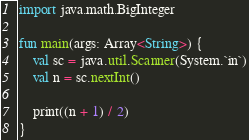<code> <loc_0><loc_0><loc_500><loc_500><_Kotlin_>import java.math.BigInteger

fun main(args: Array<String>) {
    val sc = java.util.Scanner(System.`in`)
    val n = sc.nextInt()

    print((n + 1) / 2)
}
</code> 